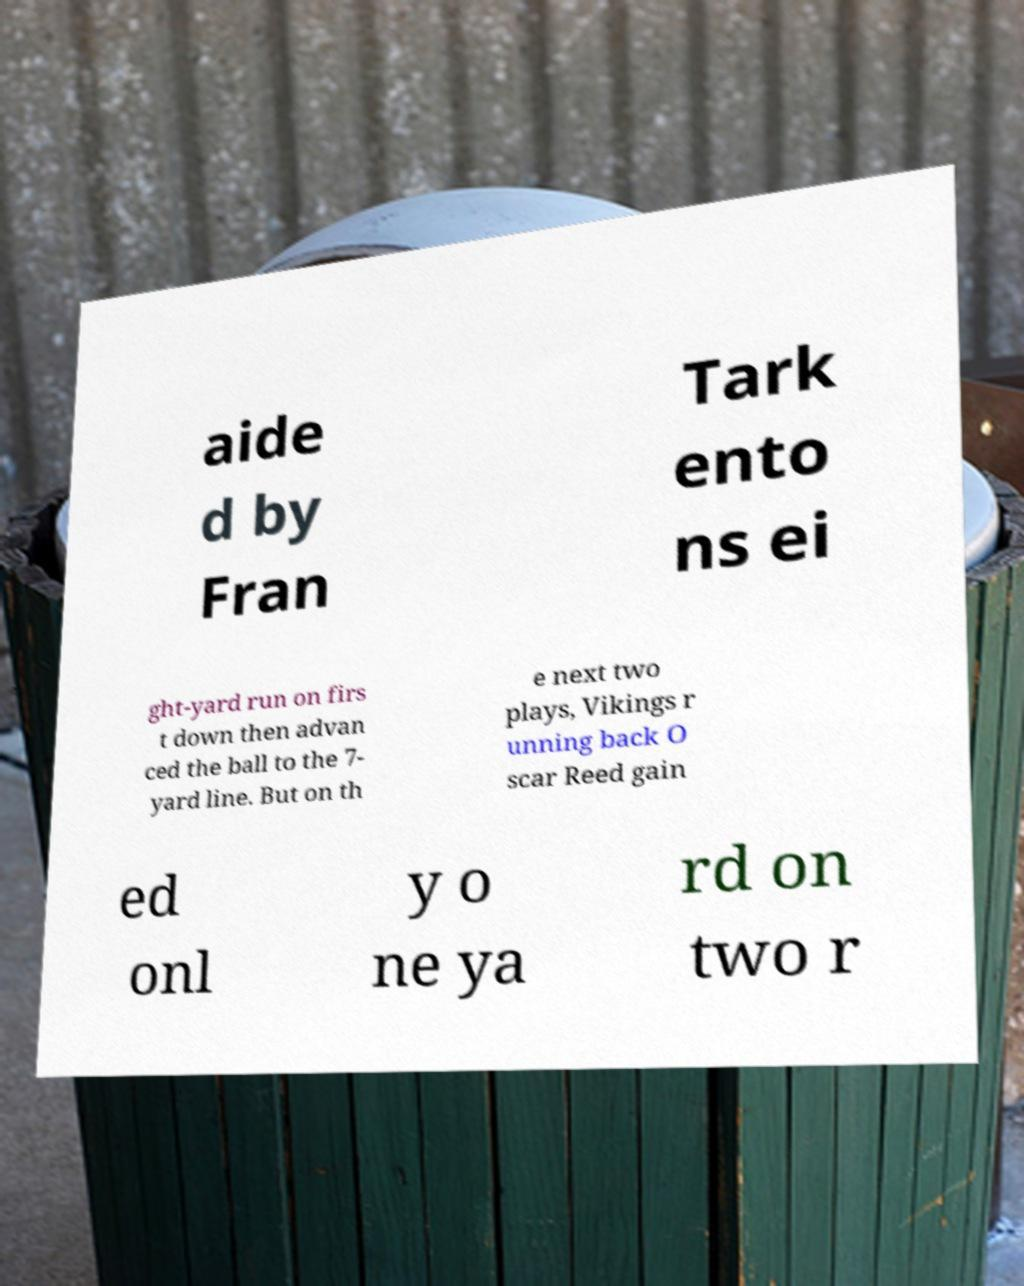Please read and relay the text visible in this image. What does it say? aide d by Fran Tark ento ns ei ght-yard run on firs t down then advan ced the ball to the 7- yard line. But on th e next two plays, Vikings r unning back O scar Reed gain ed onl y o ne ya rd on two r 